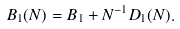<formula> <loc_0><loc_0><loc_500><loc_500>B _ { 1 } ( N ) = B _ { 1 } + N ^ { - 1 } D _ { 1 } ( N ) .</formula> 